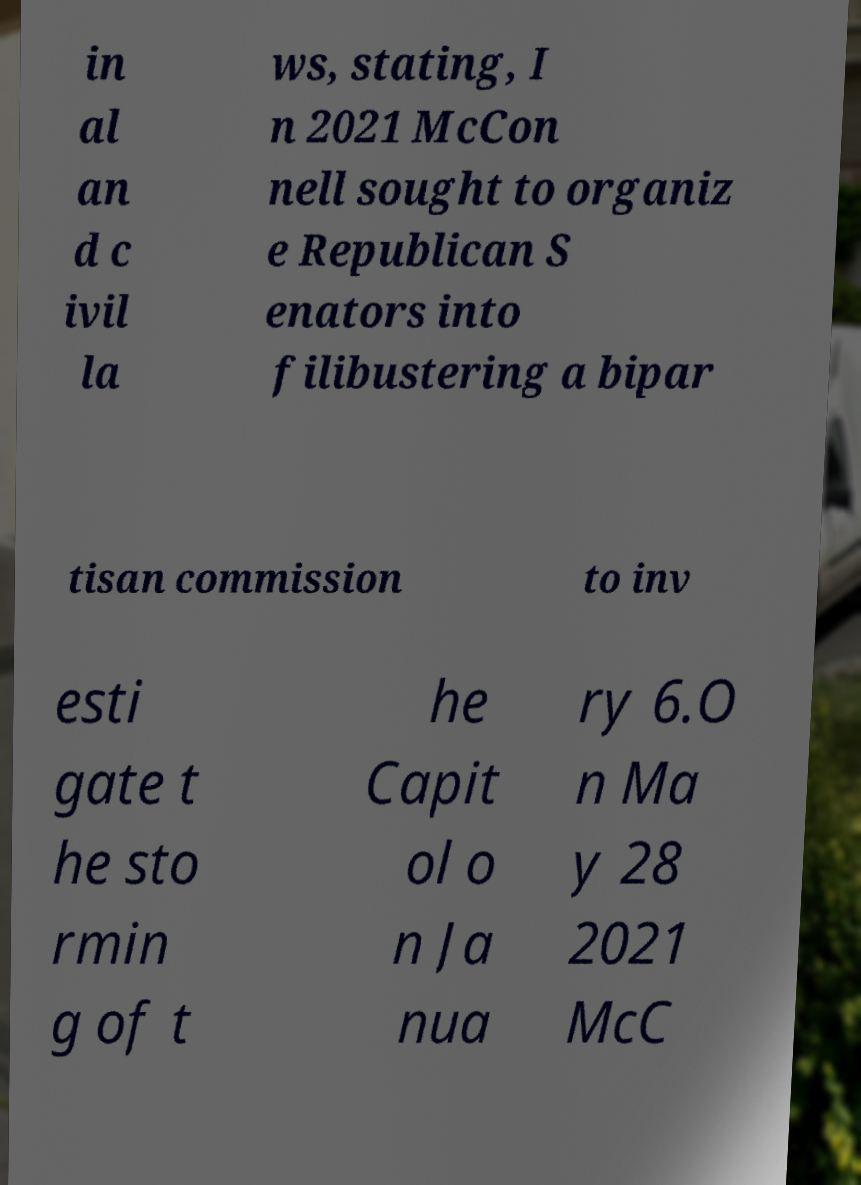There's text embedded in this image that I need extracted. Can you transcribe it verbatim? in al an d c ivil la ws, stating, I n 2021 McCon nell sought to organiz e Republican S enators into filibustering a bipar tisan commission to inv esti gate t he sto rmin g of t he Capit ol o n Ja nua ry 6.O n Ma y 28 2021 McC 